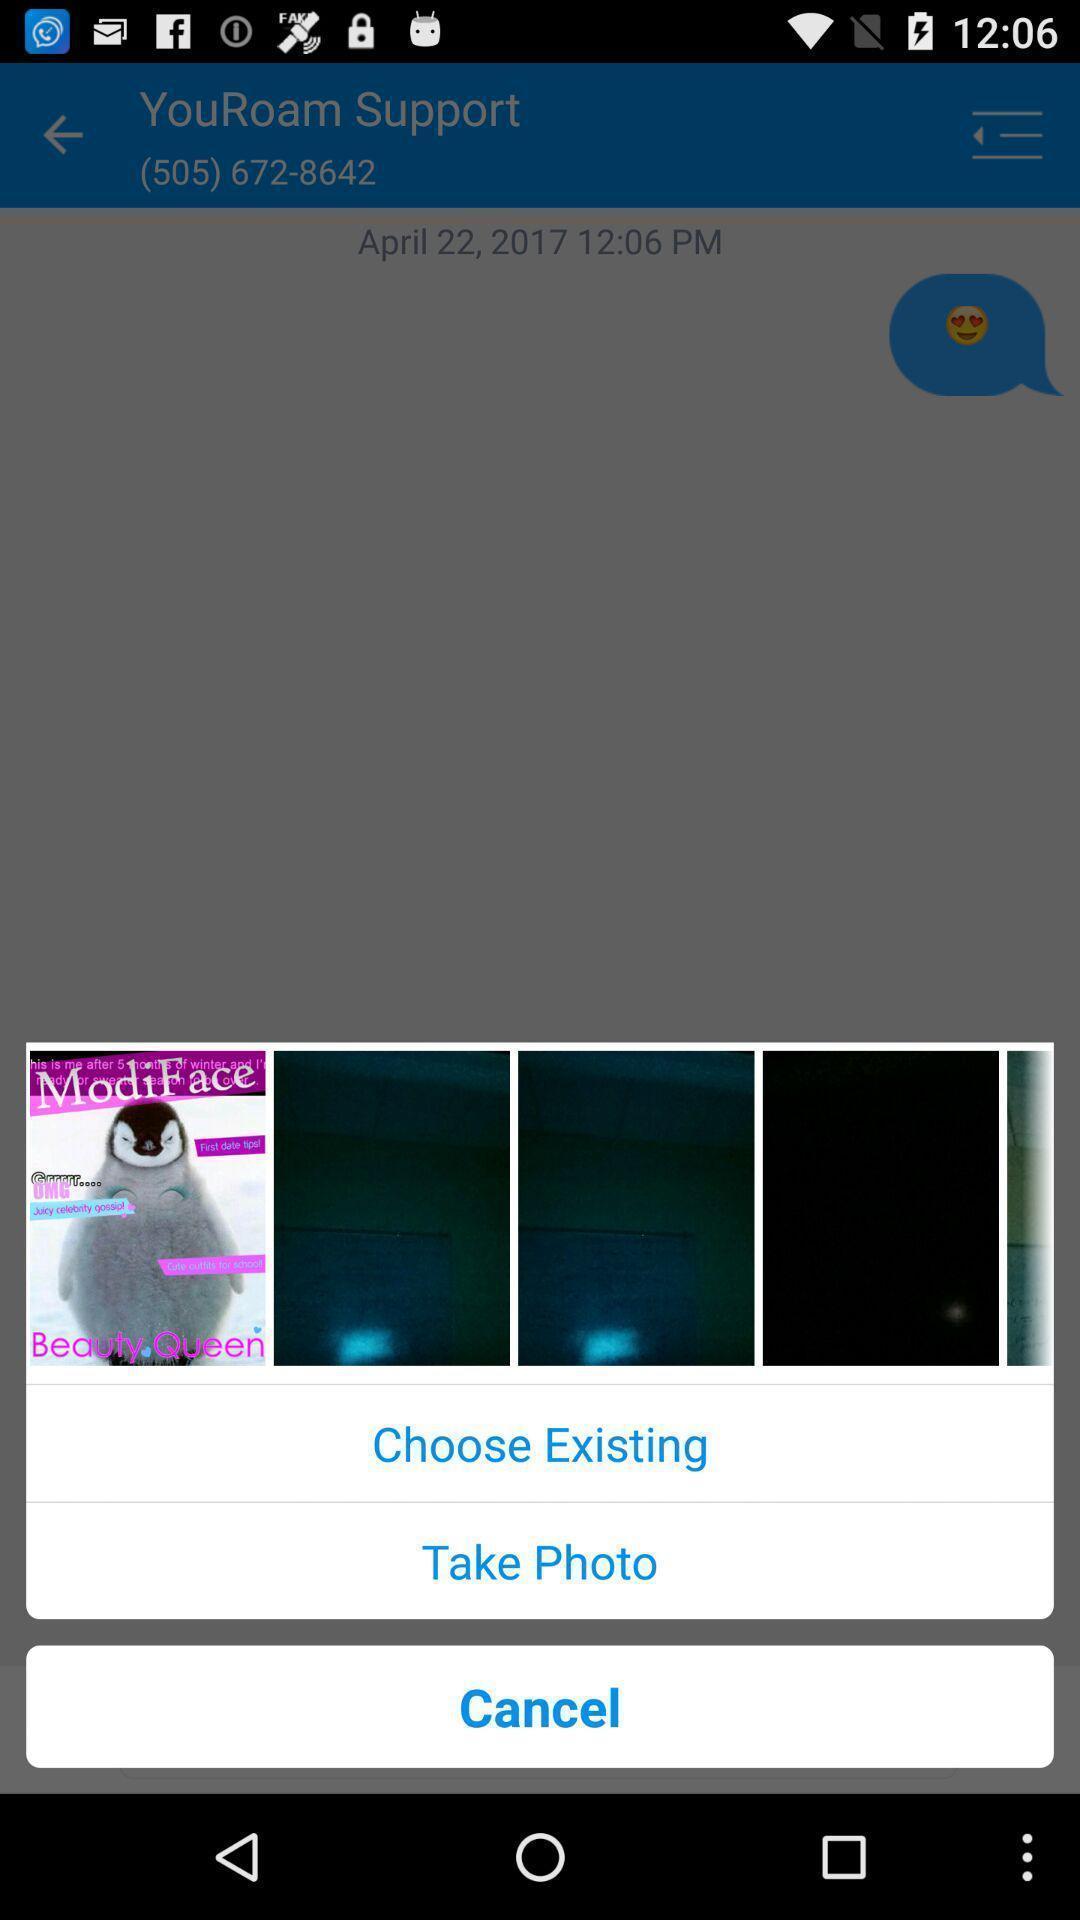What details can you identify in this image? Set of photos and options. 